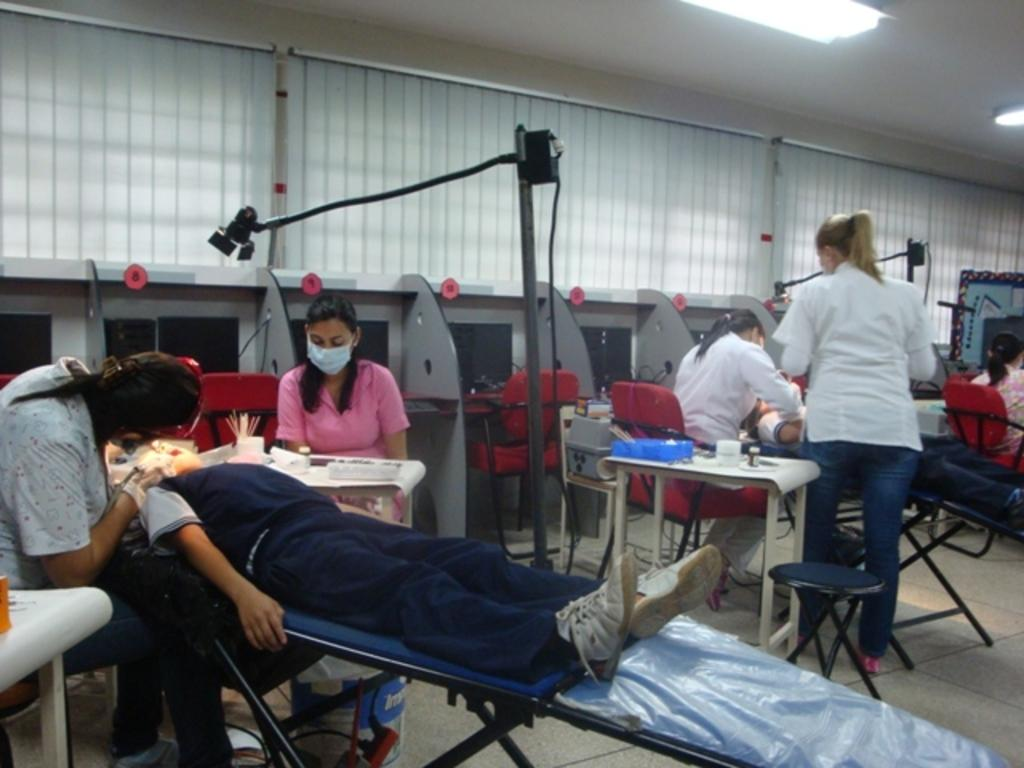Who or what can be seen in the image? There are people in the image. What are some of the people doing in the image? Some people are sitting on chairs. Can you describe the lighting in the image? There is a light on the ceiling. What type of grape is being served for breakfast in the image? There is no grape or breakfast present in the image. What material is the steel used for in the image? There is no steel present in the image. 